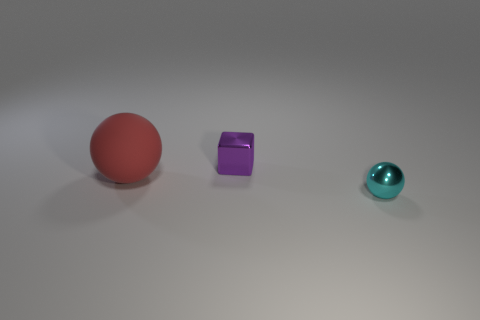What is the size of the thing that is both in front of the small purple block and to the left of the tiny cyan thing?
Offer a terse response. Large. There is a sphere that is behind the cyan shiny object; how big is it?
Make the answer very short. Large. There is a small metallic object in front of the ball that is to the left of the metallic thing that is in front of the big sphere; what shape is it?
Your answer should be compact. Sphere. What number of other objects are there of the same shape as the purple metal thing?
Give a very brief answer. 0. How many shiny things are either large red things or purple objects?
Keep it short and to the point. 1. The sphere that is behind the tiny object that is in front of the small purple block is made of what material?
Provide a succinct answer. Rubber. Are there more objects right of the large red rubber sphere than tiny purple metallic things?
Give a very brief answer. Yes. Are there any tiny cyan spheres that have the same material as the big thing?
Ensure brevity in your answer.  No. Do the small object right of the purple block and the red matte thing have the same shape?
Offer a terse response. Yes. How many small cyan metal objects are to the left of the shiny thing that is behind the tiny metallic object that is to the right of the purple block?
Provide a short and direct response. 0. 